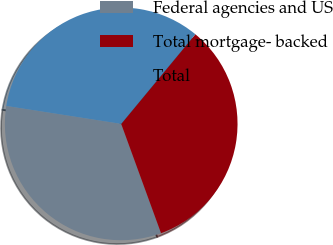Convert chart. <chart><loc_0><loc_0><loc_500><loc_500><pie_chart><fcel>Federal agencies and US<fcel>Total mortgage- backed<fcel>Total<nl><fcel>33.03%<fcel>33.44%<fcel>33.54%<nl></chart> 